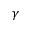Convert formula to latex. <formula><loc_0><loc_0><loc_500><loc_500>\gamma</formula> 